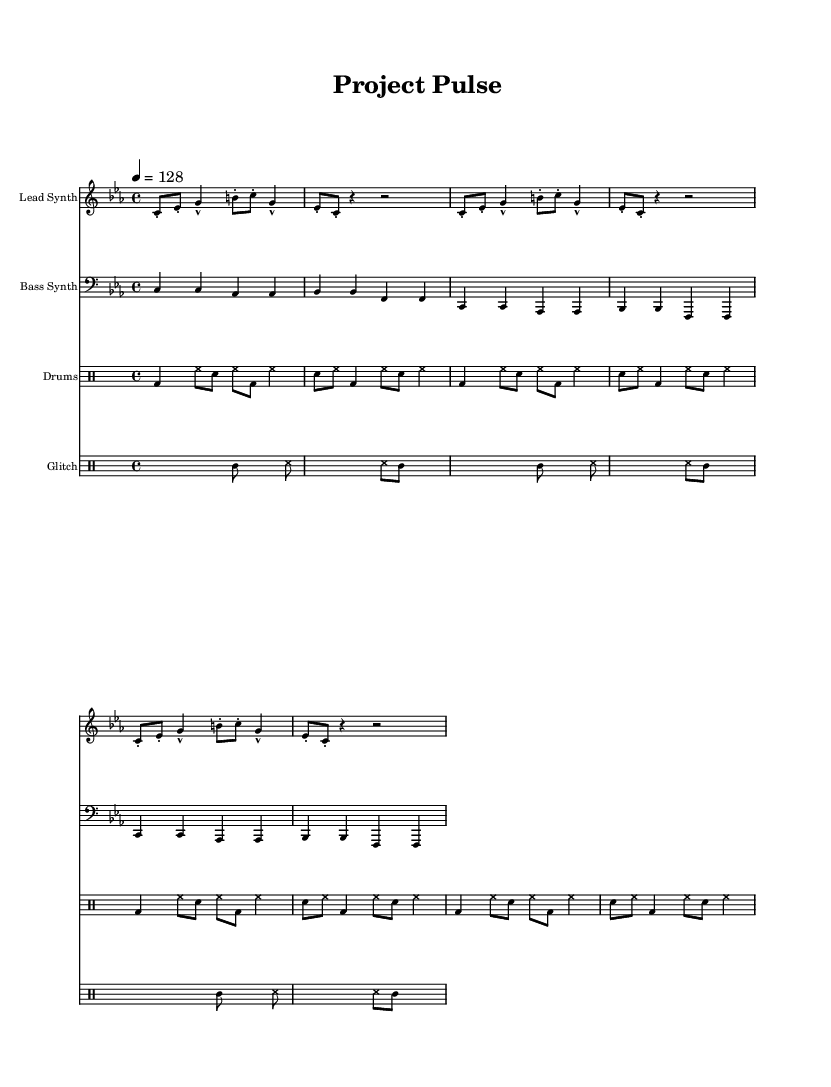What is the key signature of this music? The key signature is C minor, indicated by three flats: B flat, E flat, and A flat.
Answer: C minor What is the time signature of the piece? The time signature is 4/4, which is represented by four beats per measure, and indicates a common time feel.
Answer: 4/4 What is the tempo marking for the music? The tempo marking is indicated at the beginning, showing a tempo of quarter note equals 128 beats per minute.
Answer: 128 How many measures are in the lead synth section? The lead synth section has a total of 8 measures, counting the repeated sections.
Answer: 8 What type of percussion is used in the glitch section? The glitch section contains tambourine and sound effect notations, which indicate unconventional or sampled sounds typical in glitch music.
Answer: Glitch Which instrument has a bass clef? The bass synth is notated using a bass clef, which is standard for lower-pitched instruments like bass guitars and synthesizers.
Answer: Bass Synth How many times is the bass pattern repeated? The bass pattern is repeated 2 times as indicated by the repeat symbol, which suggests the same pattern is played twice in succession.
Answer: 2 